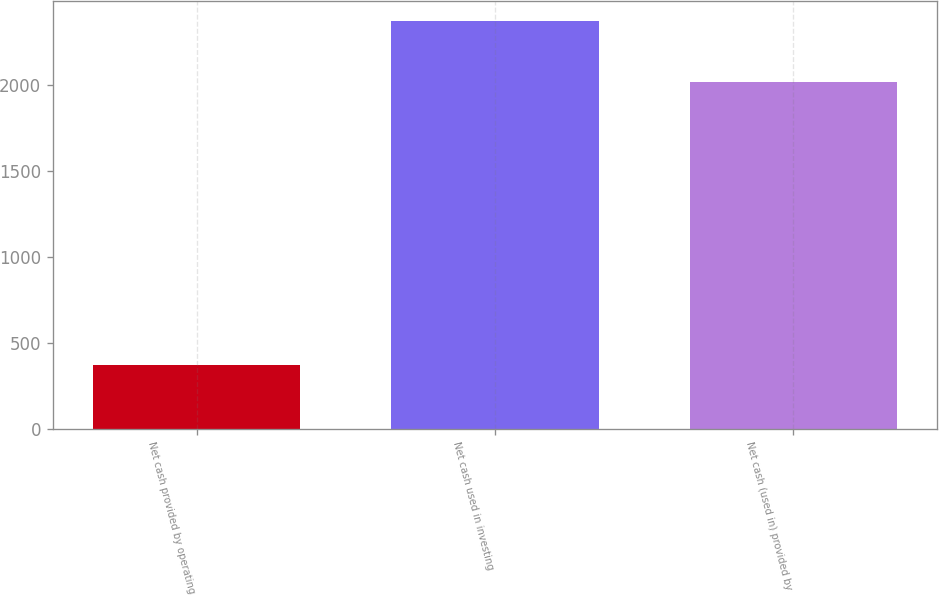Convert chart. <chart><loc_0><loc_0><loc_500><loc_500><bar_chart><fcel>Net cash provided by operating<fcel>Net cash used in investing<fcel>Net cash (used in) provided by<nl><fcel>372.2<fcel>2370<fcel>2016.4<nl></chart> 